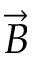<formula> <loc_0><loc_0><loc_500><loc_500>\vec { B }</formula> 